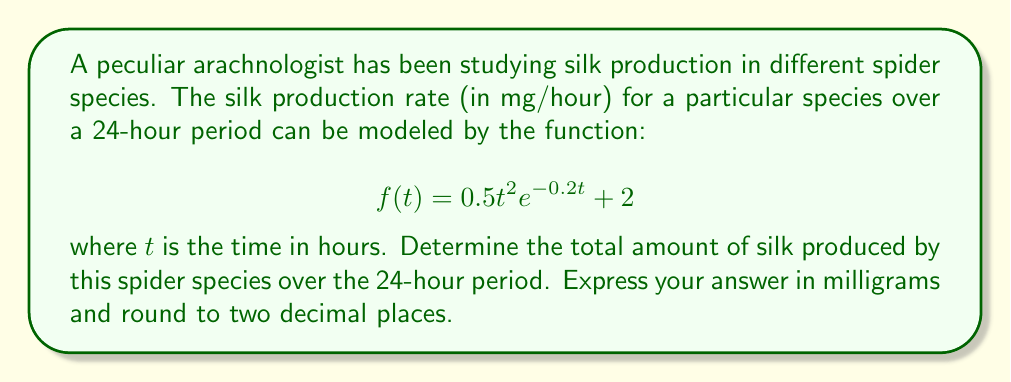Give your solution to this math problem. To solve this problem, we need to find the area under the curve of the given function from $t=0$ to $t=24$. This can be done using definite integration.

1. Set up the definite integral:
   $$\int_0^{24} (0.5t^2e^{-0.2t} + 2) dt$$

2. Split the integral into two parts:
   $$\int_0^{24} 0.5t^2e^{-0.2t} dt + \int_0^{24} 2 dt$$

3. The second part is straightforward:
   $$\int_0^{24} 2 dt = 2t \Big|_0^{24} = 48$$

4. For the first part, we need to use integration by parts twice:
   Let $u = t^2$ and $dv = e^{-0.2t}dt$
   Then $du = 2t dt$ and $v = -5e^{-0.2t}$

   $$\int t^2e^{-0.2t} dt = -5t^2e^{-0.2t} + \int 10te^{-0.2t} dt$$

   Now let $u = t$ and $dv = e^{-0.2t}dt$
   Then $du = dt$ and $v = -5e^{-0.2t}$

   $$\int 10te^{-0.2t} dt = -50te^{-0.2t} + \int 50e^{-0.2t} dt$$

   $$\int 50e^{-0.2t} dt = -250e^{-0.2t}$$

5. Putting it all together:
   $$\int t^2e^{-0.2t} dt = -5t^2e^{-0.2t} + 50te^{-0.2t} - 250e^{-0.2t} + C$$

6. Now we can evaluate the definite integral:
   $$0.5 \cdot [-5t^2e^{-0.2t} + 50te^{-0.2t} - 250e^{-0.2t}]_0^{24} + 48$$

7. Plugging in the limits:
   $$0.5 \cdot [-5(24^2)e^{-4.8} + 50(24)e^{-4.8} - 250e^{-4.8} + 250] + 48$$

8. Simplify and calculate:
   $$0.5 \cdot [-2880e^{-4.8} + 1200e^{-4.8} - 250e^{-4.8} + 250] + 48$$
   $$\approx 0.5 \cdot [-0.4091 + 0.1705 - 0.0355 + 250] + 48$$
   $$\approx 173.36$$

Therefore, the total amount of silk produced over the 24-hour period is approximately 173.36 mg.
Answer: 173.36 mg 